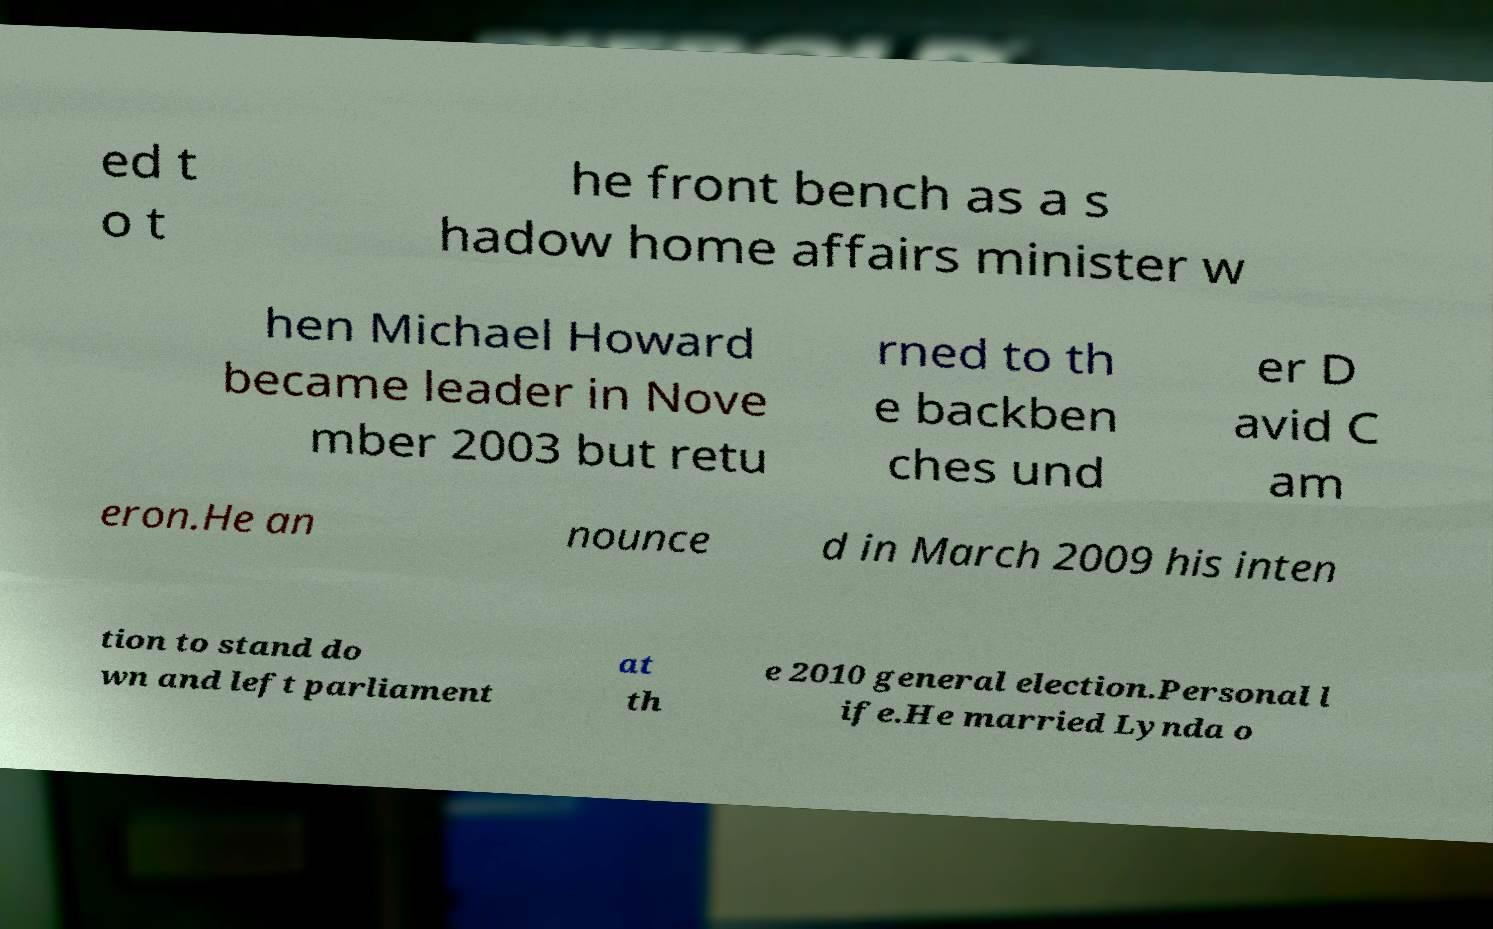For documentation purposes, I need the text within this image transcribed. Could you provide that? ed t o t he front bench as a s hadow home affairs minister w hen Michael Howard became leader in Nove mber 2003 but retu rned to th e backben ches und er D avid C am eron.He an nounce d in March 2009 his inten tion to stand do wn and left parliament at th e 2010 general election.Personal l ife.He married Lynda o 